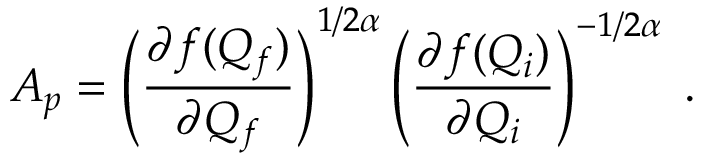Convert formula to latex. <formula><loc_0><loc_0><loc_500><loc_500>A _ { p } = \left ( \frac { \partial f ( Q _ { f } ) } { \partial Q _ { f } } \right ) ^ { 1 / 2 \alpha } \left ( \frac { \partial f ( Q _ { i } ) } { \partial Q _ { i } } \right ) ^ { - 1 / 2 \alpha } \, .</formula> 